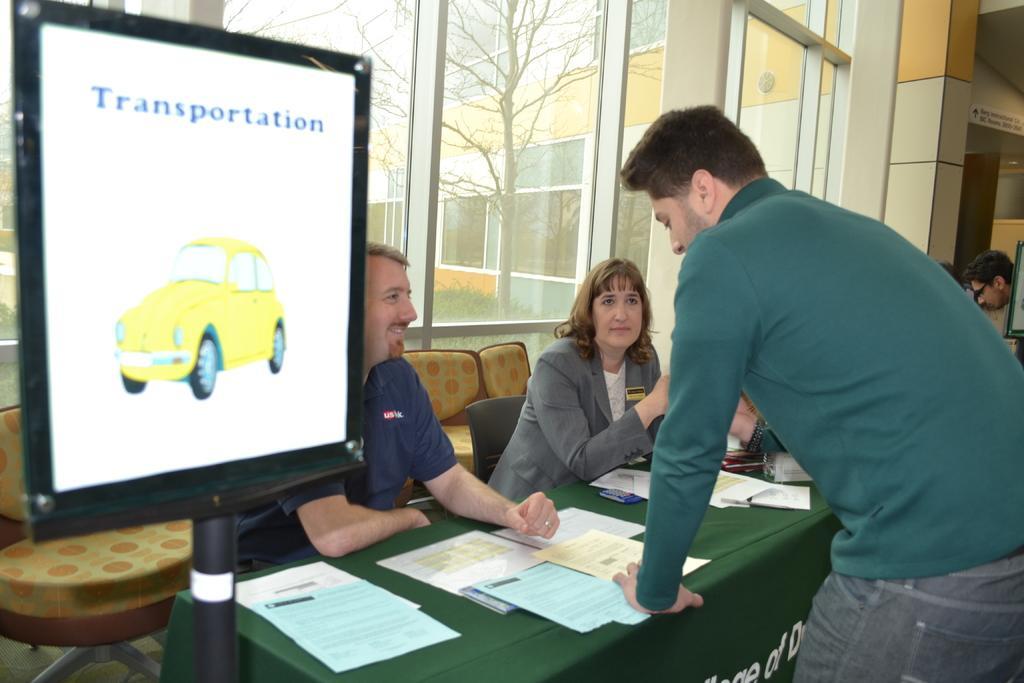Could you give a brief overview of what you see in this image? In this picture we can see two persons sitting on the chairs. This is the table. On the table there are some papers. Here we can see a person who is standing on the floor. This is the screen. On the background we can see a building. And this is the glass. 